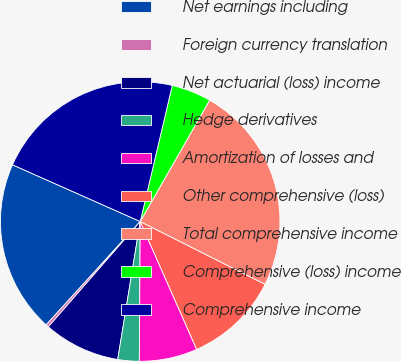Convert chart to OTSL. <chart><loc_0><loc_0><loc_500><loc_500><pie_chart><fcel>Net earnings including<fcel>Foreign currency translation<fcel>Net actuarial (loss) income<fcel>Hedge derivatives<fcel>Amortization of losses and<fcel>Other comprehensive (loss)<fcel>Total comprehensive income<fcel>Comprehensive (loss) income<fcel>Comprehensive income<nl><fcel>19.9%<fcel>0.34%<fcel>8.84%<fcel>2.47%<fcel>6.72%<fcel>10.97%<fcel>24.15%<fcel>4.59%<fcel>22.03%<nl></chart> 